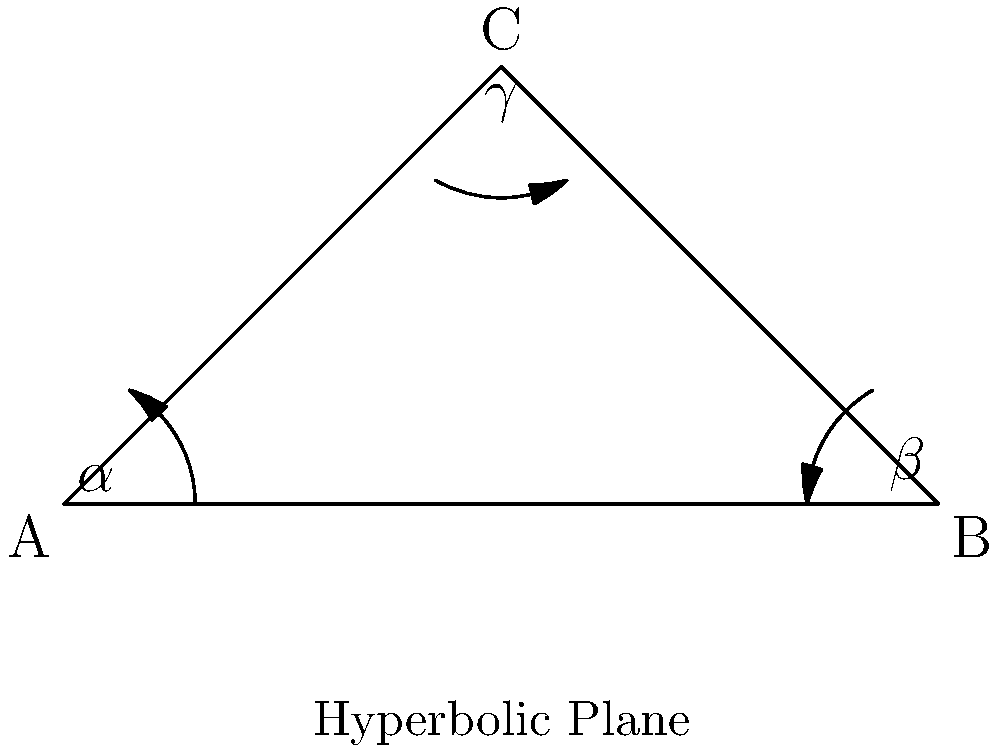Zap! You're on a hyperbolic adventure in the Electric Forest! You encounter a mysterious triangle ABC on this curved plane. The angles of this triangle are $\alpha$, $\beta$, and $\gamma$. In the hyperbolic world, you remember that the sum of these angles is always less than 180°. If $\alpha = 45°$ and $\beta = 60°$, what's the maximum possible value for $\gamma$? Let's solve this step by step, Pikachu!

1) In Euclidean geometry, we know that the sum of angles in a triangle is always 180°. But in hyperbolic geometry, it's different!

2) In hyperbolic geometry, the sum of angles in a triangle is always less than 180°. We can express this as:

   $$\alpha + \beta + \gamma < 180°$$

3) We're given that $\alpha = 45°$ and $\beta = 60°$. Let's substitute these:

   $$45° + 60° + \gamma < 180°$$

4) Simplify:

   $$105° + \gamma < 180°$$

5) To find the maximum possible value for $\gamma$, we need to consider the closest value to 180° without reaching it. In other words:

   $$105° + \gamma = 180° - \epsilon$$

   Where $\epsilon$ is an infinitesimally small positive number.

6) Solve for $\gamma$:

   $$\gamma = 180° - 105° - \epsilon = 75° - \epsilon$$

7) As $\epsilon$ approaches zero, $\gamma$ approaches its maximum value.

Therefore, the maximum possible value for $\gamma$ is just slightly less than 75°.
Answer: $75° - \epsilon$, where $\epsilon$ is an infinitesimally small positive number 